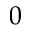Convert formula to latex. <formula><loc_0><loc_0><loc_500><loc_500>0</formula> 